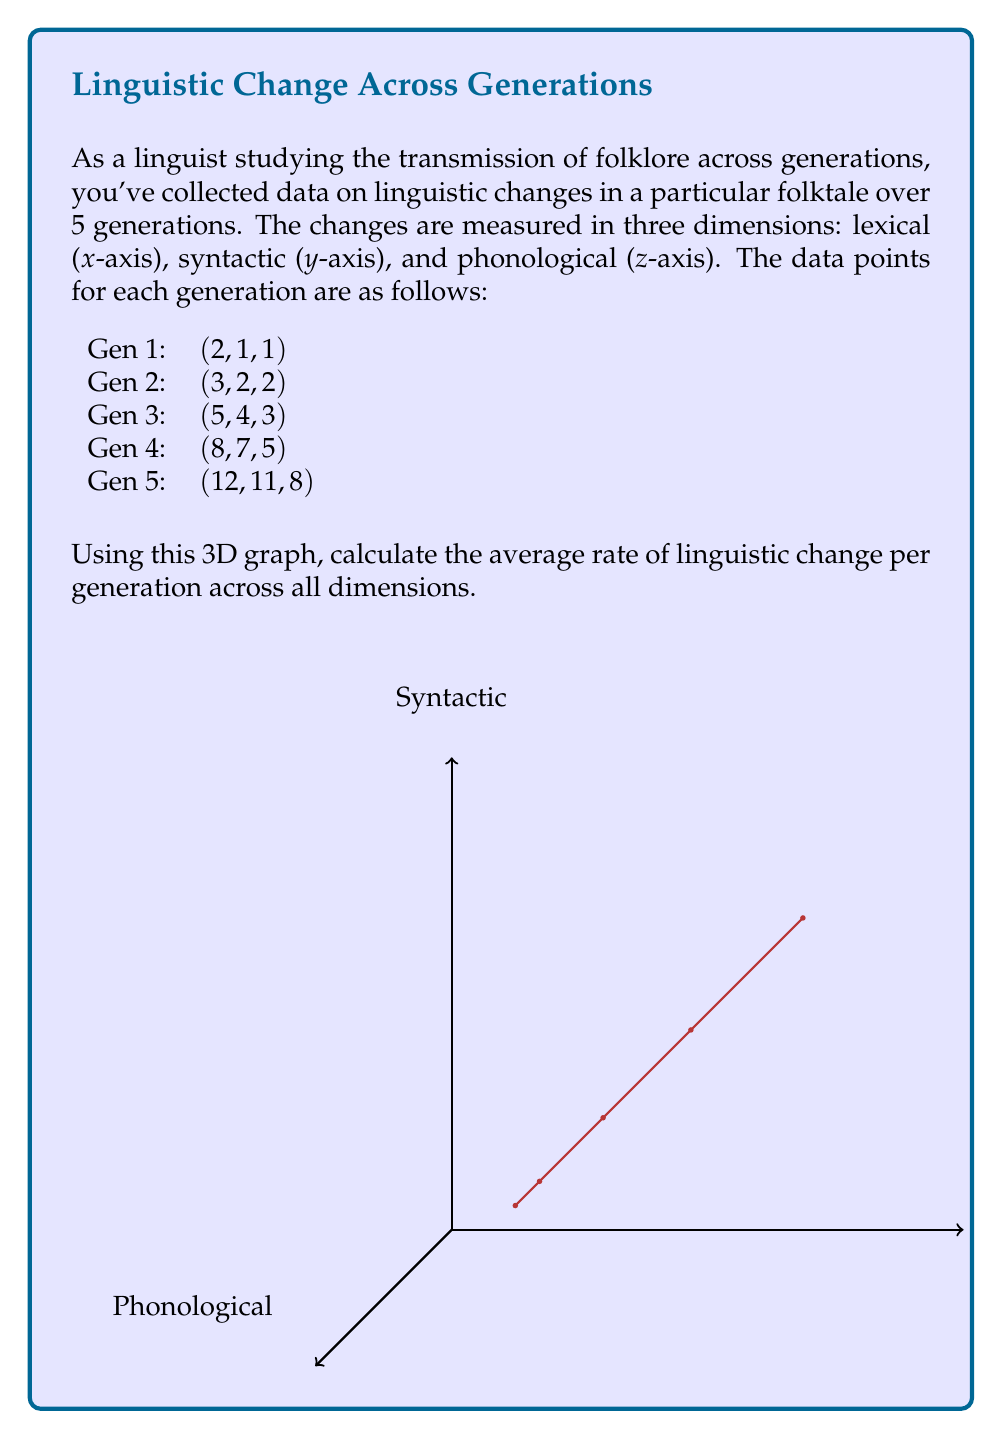Could you help me with this problem? To solve this problem, we'll follow these steps:

1) First, calculate the total change in each dimension:
   Lexical: $12 - 2 = 10$
   Syntactic: $11 - 1 = 10$
   Phonological: $8 - 1 = 7$

2) Calculate the average change across all dimensions:
   $\frac{10 + 10 + 7}{3} = 9$

3) To find the rate of change per generation, divide by the number of intervals between generations (4 in this case):
   $\frac{9}{4} = 2.25$

4) To express this as a vector, we need to calculate the average change per dimension per generation:
   Lexical: $\frac{10}{4} = 2.5$
   Syntactic: $\frac{10}{4} = 2.5$
   Phonological: $\frac{7}{4} = 1.75$

5) The rate of change vector is therefore $(2.5, 2.5, 1.75)$

6) To find the magnitude of this vector (which represents the average rate of change across all dimensions), we use the formula:

   $$\sqrt{(2.5)^2 + (2.5)^2 + (1.75)^2} = \sqrt{6.25 + 6.25 + 3.0625} = \sqrt{15.5625} \approx 3.945$$

Therefore, the average rate of linguistic change per generation across all dimensions is approximately 3.945 units.
Answer: $3.945$ units per generation 